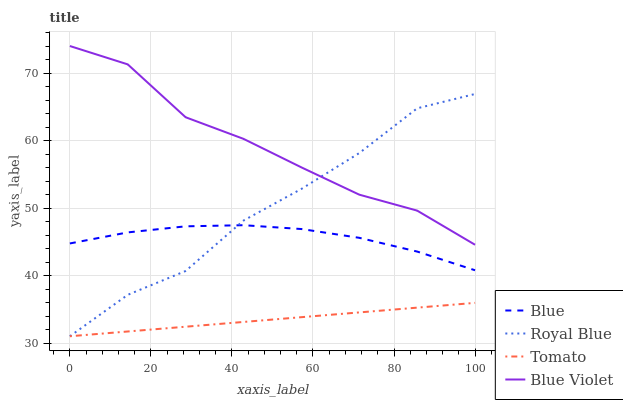Does Tomato have the minimum area under the curve?
Answer yes or no. Yes. Does Blue Violet have the maximum area under the curve?
Answer yes or no. Yes. Does Royal Blue have the minimum area under the curve?
Answer yes or no. No. Does Royal Blue have the maximum area under the curve?
Answer yes or no. No. Is Tomato the smoothest?
Answer yes or no. Yes. Is Royal Blue the roughest?
Answer yes or no. Yes. Is Royal Blue the smoothest?
Answer yes or no. No. Is Tomato the roughest?
Answer yes or no. No. Does Royal Blue have the lowest value?
Answer yes or no. Yes. Does Blue Violet have the lowest value?
Answer yes or no. No. Does Blue Violet have the highest value?
Answer yes or no. Yes. Does Royal Blue have the highest value?
Answer yes or no. No. Is Tomato less than Blue?
Answer yes or no. Yes. Is Blue greater than Tomato?
Answer yes or no. Yes. Does Blue intersect Royal Blue?
Answer yes or no. Yes. Is Blue less than Royal Blue?
Answer yes or no. No. Is Blue greater than Royal Blue?
Answer yes or no. No. Does Tomato intersect Blue?
Answer yes or no. No. 